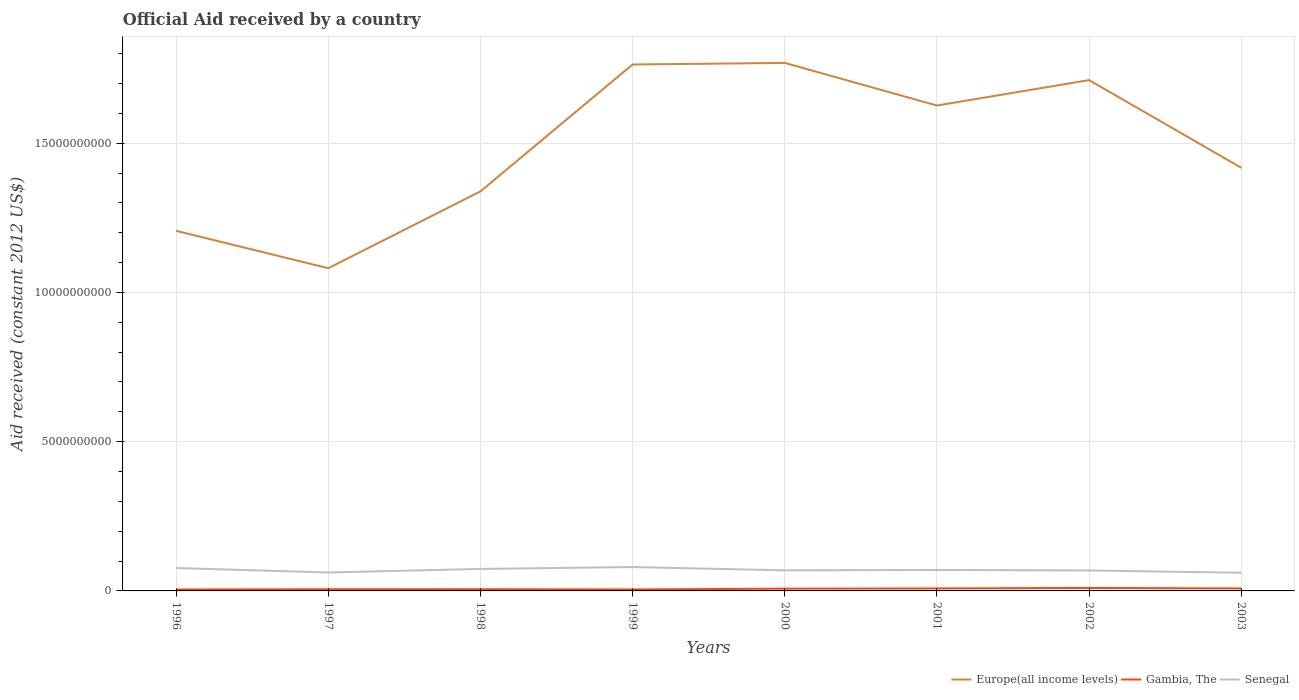Across all years, what is the maximum net official aid received in Gambia, The?
Offer a terse response. 4.86e+07. In which year was the net official aid received in Gambia, The maximum?
Offer a terse response. 1996. What is the total net official aid received in Senegal in the graph?
Keep it short and to the point. 1.58e+08. What is the difference between the highest and the second highest net official aid received in Gambia, The?
Offer a very short reply. 5.02e+07. What is the difference between the highest and the lowest net official aid received in Senegal?
Offer a terse response. 4. Does the graph contain any zero values?
Ensure brevity in your answer.  No. Where does the legend appear in the graph?
Provide a succinct answer. Bottom right. What is the title of the graph?
Your answer should be very brief. Official Aid received by a country. What is the label or title of the Y-axis?
Ensure brevity in your answer.  Aid received (constant 2012 US$). What is the Aid received (constant 2012 US$) in Europe(all income levels) in 1996?
Your answer should be very brief. 1.21e+1. What is the Aid received (constant 2012 US$) of Gambia, The in 1996?
Give a very brief answer. 4.86e+07. What is the Aid received (constant 2012 US$) in Senegal in 1996?
Keep it short and to the point. 7.67e+08. What is the Aid received (constant 2012 US$) in Europe(all income levels) in 1997?
Your answer should be compact. 1.08e+1. What is the Aid received (constant 2012 US$) of Gambia, The in 1997?
Make the answer very short. 5.61e+07. What is the Aid received (constant 2012 US$) of Senegal in 1997?
Your response must be concise. 6.17e+08. What is the Aid received (constant 2012 US$) in Europe(all income levels) in 1998?
Provide a succinct answer. 1.34e+1. What is the Aid received (constant 2012 US$) of Gambia, The in 1998?
Offer a very short reply. 5.69e+07. What is the Aid received (constant 2012 US$) in Senegal in 1998?
Your answer should be very brief. 7.37e+08. What is the Aid received (constant 2012 US$) of Europe(all income levels) in 1999?
Your answer should be very brief. 1.76e+1. What is the Aid received (constant 2012 US$) of Gambia, The in 1999?
Make the answer very short. 4.95e+07. What is the Aid received (constant 2012 US$) of Senegal in 1999?
Your response must be concise. 8.00e+08. What is the Aid received (constant 2012 US$) of Europe(all income levels) in 2000?
Offer a very short reply. 1.77e+1. What is the Aid received (constant 2012 US$) in Gambia, The in 2000?
Ensure brevity in your answer.  7.57e+07. What is the Aid received (constant 2012 US$) in Senegal in 2000?
Ensure brevity in your answer.  6.89e+08. What is the Aid received (constant 2012 US$) of Europe(all income levels) in 2001?
Provide a short and direct response. 1.63e+1. What is the Aid received (constant 2012 US$) of Gambia, The in 2001?
Offer a terse response. 8.32e+07. What is the Aid received (constant 2012 US$) of Senegal in 2001?
Ensure brevity in your answer.  7.03e+08. What is the Aid received (constant 2012 US$) in Europe(all income levels) in 2002?
Give a very brief answer. 1.71e+1. What is the Aid received (constant 2012 US$) in Gambia, The in 2002?
Ensure brevity in your answer.  9.87e+07. What is the Aid received (constant 2012 US$) in Senegal in 2002?
Your answer should be very brief. 6.85e+08. What is the Aid received (constant 2012 US$) of Europe(all income levels) in 2003?
Your answer should be very brief. 1.42e+1. What is the Aid received (constant 2012 US$) of Gambia, The in 2003?
Offer a terse response. 8.30e+07. What is the Aid received (constant 2012 US$) of Senegal in 2003?
Offer a very short reply. 6.09e+08. Across all years, what is the maximum Aid received (constant 2012 US$) of Europe(all income levels)?
Offer a terse response. 1.77e+1. Across all years, what is the maximum Aid received (constant 2012 US$) of Gambia, The?
Make the answer very short. 9.87e+07. Across all years, what is the maximum Aid received (constant 2012 US$) in Senegal?
Your answer should be very brief. 8.00e+08. Across all years, what is the minimum Aid received (constant 2012 US$) in Europe(all income levels)?
Offer a terse response. 1.08e+1. Across all years, what is the minimum Aid received (constant 2012 US$) of Gambia, The?
Keep it short and to the point. 4.86e+07. Across all years, what is the minimum Aid received (constant 2012 US$) in Senegal?
Give a very brief answer. 6.09e+08. What is the total Aid received (constant 2012 US$) in Europe(all income levels) in the graph?
Your response must be concise. 1.19e+11. What is the total Aid received (constant 2012 US$) in Gambia, The in the graph?
Offer a very short reply. 5.52e+08. What is the total Aid received (constant 2012 US$) of Senegal in the graph?
Provide a succinct answer. 5.61e+09. What is the difference between the Aid received (constant 2012 US$) in Europe(all income levels) in 1996 and that in 1997?
Give a very brief answer. 1.25e+09. What is the difference between the Aid received (constant 2012 US$) in Gambia, The in 1996 and that in 1997?
Offer a very short reply. -7.59e+06. What is the difference between the Aid received (constant 2012 US$) in Senegal in 1996 and that in 1997?
Your response must be concise. 1.49e+08. What is the difference between the Aid received (constant 2012 US$) in Europe(all income levels) in 1996 and that in 1998?
Give a very brief answer. -1.32e+09. What is the difference between the Aid received (constant 2012 US$) in Gambia, The in 1996 and that in 1998?
Offer a terse response. -8.32e+06. What is the difference between the Aid received (constant 2012 US$) of Senegal in 1996 and that in 1998?
Make the answer very short. 2.94e+07. What is the difference between the Aid received (constant 2012 US$) in Europe(all income levels) in 1996 and that in 1999?
Ensure brevity in your answer.  -5.57e+09. What is the difference between the Aid received (constant 2012 US$) in Gambia, The in 1996 and that in 1999?
Provide a short and direct response. -9.20e+05. What is the difference between the Aid received (constant 2012 US$) in Senegal in 1996 and that in 1999?
Ensure brevity in your answer.  -3.32e+07. What is the difference between the Aid received (constant 2012 US$) in Europe(all income levels) in 1996 and that in 2000?
Provide a short and direct response. -5.63e+09. What is the difference between the Aid received (constant 2012 US$) of Gambia, The in 1996 and that in 2000?
Your answer should be compact. -2.72e+07. What is the difference between the Aid received (constant 2012 US$) in Senegal in 1996 and that in 2000?
Your response must be concise. 7.72e+07. What is the difference between the Aid received (constant 2012 US$) of Europe(all income levels) in 1996 and that in 2001?
Your answer should be very brief. -4.20e+09. What is the difference between the Aid received (constant 2012 US$) of Gambia, The in 1996 and that in 2001?
Provide a short and direct response. -3.46e+07. What is the difference between the Aid received (constant 2012 US$) of Senegal in 1996 and that in 2001?
Provide a succinct answer. 6.37e+07. What is the difference between the Aid received (constant 2012 US$) in Europe(all income levels) in 1996 and that in 2002?
Provide a succinct answer. -5.05e+09. What is the difference between the Aid received (constant 2012 US$) in Gambia, The in 1996 and that in 2002?
Provide a succinct answer. -5.02e+07. What is the difference between the Aid received (constant 2012 US$) in Senegal in 1996 and that in 2002?
Keep it short and to the point. 8.17e+07. What is the difference between the Aid received (constant 2012 US$) in Europe(all income levels) in 1996 and that in 2003?
Ensure brevity in your answer.  -2.11e+09. What is the difference between the Aid received (constant 2012 US$) of Gambia, The in 1996 and that in 2003?
Your response must be concise. -3.44e+07. What is the difference between the Aid received (constant 2012 US$) in Senegal in 1996 and that in 2003?
Make the answer very short. 1.58e+08. What is the difference between the Aid received (constant 2012 US$) in Europe(all income levels) in 1997 and that in 1998?
Provide a succinct answer. -2.57e+09. What is the difference between the Aid received (constant 2012 US$) of Gambia, The in 1997 and that in 1998?
Provide a short and direct response. -7.30e+05. What is the difference between the Aid received (constant 2012 US$) in Senegal in 1997 and that in 1998?
Offer a very short reply. -1.20e+08. What is the difference between the Aid received (constant 2012 US$) of Europe(all income levels) in 1997 and that in 1999?
Provide a succinct answer. -6.82e+09. What is the difference between the Aid received (constant 2012 US$) of Gambia, The in 1997 and that in 1999?
Give a very brief answer. 6.67e+06. What is the difference between the Aid received (constant 2012 US$) of Senegal in 1997 and that in 1999?
Offer a terse response. -1.83e+08. What is the difference between the Aid received (constant 2012 US$) in Europe(all income levels) in 1997 and that in 2000?
Your answer should be compact. -6.88e+09. What is the difference between the Aid received (constant 2012 US$) of Gambia, The in 1997 and that in 2000?
Provide a short and direct response. -1.96e+07. What is the difference between the Aid received (constant 2012 US$) in Senegal in 1997 and that in 2000?
Your answer should be compact. -7.22e+07. What is the difference between the Aid received (constant 2012 US$) of Europe(all income levels) in 1997 and that in 2001?
Your answer should be compact. -5.45e+09. What is the difference between the Aid received (constant 2012 US$) of Gambia, The in 1997 and that in 2001?
Offer a terse response. -2.71e+07. What is the difference between the Aid received (constant 2012 US$) in Senegal in 1997 and that in 2001?
Offer a terse response. -8.58e+07. What is the difference between the Aid received (constant 2012 US$) of Europe(all income levels) in 1997 and that in 2002?
Offer a terse response. -6.30e+09. What is the difference between the Aid received (constant 2012 US$) in Gambia, The in 1997 and that in 2002?
Your response must be concise. -4.26e+07. What is the difference between the Aid received (constant 2012 US$) of Senegal in 1997 and that in 2002?
Your answer should be very brief. -6.78e+07. What is the difference between the Aid received (constant 2012 US$) in Europe(all income levels) in 1997 and that in 2003?
Provide a succinct answer. -3.37e+09. What is the difference between the Aid received (constant 2012 US$) in Gambia, The in 1997 and that in 2003?
Ensure brevity in your answer.  -2.69e+07. What is the difference between the Aid received (constant 2012 US$) of Senegal in 1997 and that in 2003?
Provide a short and direct response. 8.65e+06. What is the difference between the Aid received (constant 2012 US$) of Europe(all income levels) in 1998 and that in 1999?
Offer a terse response. -4.25e+09. What is the difference between the Aid received (constant 2012 US$) of Gambia, The in 1998 and that in 1999?
Provide a succinct answer. 7.40e+06. What is the difference between the Aid received (constant 2012 US$) of Senegal in 1998 and that in 1999?
Offer a very short reply. -6.26e+07. What is the difference between the Aid received (constant 2012 US$) in Europe(all income levels) in 1998 and that in 2000?
Offer a very short reply. -4.30e+09. What is the difference between the Aid received (constant 2012 US$) in Gambia, The in 1998 and that in 2000?
Your answer should be very brief. -1.88e+07. What is the difference between the Aid received (constant 2012 US$) of Senegal in 1998 and that in 2000?
Your answer should be compact. 4.78e+07. What is the difference between the Aid received (constant 2012 US$) in Europe(all income levels) in 1998 and that in 2001?
Keep it short and to the point. -2.88e+09. What is the difference between the Aid received (constant 2012 US$) in Gambia, The in 1998 and that in 2001?
Provide a succinct answer. -2.63e+07. What is the difference between the Aid received (constant 2012 US$) of Senegal in 1998 and that in 2001?
Your answer should be compact. 3.43e+07. What is the difference between the Aid received (constant 2012 US$) in Europe(all income levels) in 1998 and that in 2002?
Provide a short and direct response. -3.73e+09. What is the difference between the Aid received (constant 2012 US$) of Gambia, The in 1998 and that in 2002?
Keep it short and to the point. -4.19e+07. What is the difference between the Aid received (constant 2012 US$) in Senegal in 1998 and that in 2002?
Your answer should be compact. 5.23e+07. What is the difference between the Aid received (constant 2012 US$) of Europe(all income levels) in 1998 and that in 2003?
Your response must be concise. -7.91e+08. What is the difference between the Aid received (constant 2012 US$) of Gambia, The in 1998 and that in 2003?
Provide a short and direct response. -2.61e+07. What is the difference between the Aid received (constant 2012 US$) in Senegal in 1998 and that in 2003?
Provide a short and direct response. 1.29e+08. What is the difference between the Aid received (constant 2012 US$) of Europe(all income levels) in 1999 and that in 2000?
Your answer should be compact. -5.37e+07. What is the difference between the Aid received (constant 2012 US$) in Gambia, The in 1999 and that in 2000?
Ensure brevity in your answer.  -2.62e+07. What is the difference between the Aid received (constant 2012 US$) of Senegal in 1999 and that in 2000?
Ensure brevity in your answer.  1.10e+08. What is the difference between the Aid received (constant 2012 US$) of Europe(all income levels) in 1999 and that in 2001?
Make the answer very short. 1.37e+09. What is the difference between the Aid received (constant 2012 US$) of Gambia, The in 1999 and that in 2001?
Offer a very short reply. -3.37e+07. What is the difference between the Aid received (constant 2012 US$) of Senegal in 1999 and that in 2001?
Your response must be concise. 9.70e+07. What is the difference between the Aid received (constant 2012 US$) of Europe(all income levels) in 1999 and that in 2002?
Give a very brief answer. 5.22e+08. What is the difference between the Aid received (constant 2012 US$) in Gambia, The in 1999 and that in 2002?
Your answer should be compact. -4.93e+07. What is the difference between the Aid received (constant 2012 US$) in Senegal in 1999 and that in 2002?
Make the answer very short. 1.15e+08. What is the difference between the Aid received (constant 2012 US$) of Europe(all income levels) in 1999 and that in 2003?
Keep it short and to the point. 3.46e+09. What is the difference between the Aid received (constant 2012 US$) of Gambia, The in 1999 and that in 2003?
Provide a succinct answer. -3.35e+07. What is the difference between the Aid received (constant 2012 US$) in Senegal in 1999 and that in 2003?
Ensure brevity in your answer.  1.91e+08. What is the difference between the Aid received (constant 2012 US$) of Europe(all income levels) in 2000 and that in 2001?
Offer a very short reply. 1.43e+09. What is the difference between the Aid received (constant 2012 US$) of Gambia, The in 2000 and that in 2001?
Your answer should be compact. -7.49e+06. What is the difference between the Aid received (constant 2012 US$) of Senegal in 2000 and that in 2001?
Provide a succinct answer. -1.35e+07. What is the difference between the Aid received (constant 2012 US$) in Europe(all income levels) in 2000 and that in 2002?
Provide a short and direct response. 5.76e+08. What is the difference between the Aid received (constant 2012 US$) in Gambia, The in 2000 and that in 2002?
Offer a terse response. -2.30e+07. What is the difference between the Aid received (constant 2012 US$) in Senegal in 2000 and that in 2002?
Make the answer very short. 4.49e+06. What is the difference between the Aid received (constant 2012 US$) in Europe(all income levels) in 2000 and that in 2003?
Give a very brief answer. 3.51e+09. What is the difference between the Aid received (constant 2012 US$) in Gambia, The in 2000 and that in 2003?
Offer a very short reply. -7.29e+06. What is the difference between the Aid received (constant 2012 US$) in Senegal in 2000 and that in 2003?
Provide a succinct answer. 8.09e+07. What is the difference between the Aid received (constant 2012 US$) of Europe(all income levels) in 2001 and that in 2002?
Your response must be concise. -8.52e+08. What is the difference between the Aid received (constant 2012 US$) of Gambia, The in 2001 and that in 2002?
Your response must be concise. -1.55e+07. What is the difference between the Aid received (constant 2012 US$) in Senegal in 2001 and that in 2002?
Your answer should be compact. 1.80e+07. What is the difference between the Aid received (constant 2012 US$) in Europe(all income levels) in 2001 and that in 2003?
Ensure brevity in your answer.  2.08e+09. What is the difference between the Aid received (constant 2012 US$) of Senegal in 2001 and that in 2003?
Offer a terse response. 9.44e+07. What is the difference between the Aid received (constant 2012 US$) of Europe(all income levels) in 2002 and that in 2003?
Provide a succinct answer. 2.94e+09. What is the difference between the Aid received (constant 2012 US$) in Gambia, The in 2002 and that in 2003?
Your response must be concise. 1.57e+07. What is the difference between the Aid received (constant 2012 US$) in Senegal in 2002 and that in 2003?
Offer a very short reply. 7.64e+07. What is the difference between the Aid received (constant 2012 US$) in Europe(all income levels) in 1996 and the Aid received (constant 2012 US$) in Gambia, The in 1997?
Ensure brevity in your answer.  1.20e+1. What is the difference between the Aid received (constant 2012 US$) of Europe(all income levels) in 1996 and the Aid received (constant 2012 US$) of Senegal in 1997?
Offer a terse response. 1.14e+1. What is the difference between the Aid received (constant 2012 US$) of Gambia, The in 1996 and the Aid received (constant 2012 US$) of Senegal in 1997?
Make the answer very short. -5.69e+08. What is the difference between the Aid received (constant 2012 US$) of Europe(all income levels) in 1996 and the Aid received (constant 2012 US$) of Gambia, The in 1998?
Make the answer very short. 1.20e+1. What is the difference between the Aid received (constant 2012 US$) in Europe(all income levels) in 1996 and the Aid received (constant 2012 US$) in Senegal in 1998?
Give a very brief answer. 1.13e+1. What is the difference between the Aid received (constant 2012 US$) of Gambia, The in 1996 and the Aid received (constant 2012 US$) of Senegal in 1998?
Your answer should be very brief. -6.89e+08. What is the difference between the Aid received (constant 2012 US$) of Europe(all income levels) in 1996 and the Aid received (constant 2012 US$) of Gambia, The in 1999?
Offer a very short reply. 1.20e+1. What is the difference between the Aid received (constant 2012 US$) in Europe(all income levels) in 1996 and the Aid received (constant 2012 US$) in Senegal in 1999?
Make the answer very short. 1.13e+1. What is the difference between the Aid received (constant 2012 US$) of Gambia, The in 1996 and the Aid received (constant 2012 US$) of Senegal in 1999?
Provide a short and direct response. -7.51e+08. What is the difference between the Aid received (constant 2012 US$) in Europe(all income levels) in 1996 and the Aid received (constant 2012 US$) in Gambia, The in 2000?
Make the answer very short. 1.20e+1. What is the difference between the Aid received (constant 2012 US$) of Europe(all income levels) in 1996 and the Aid received (constant 2012 US$) of Senegal in 2000?
Give a very brief answer. 1.14e+1. What is the difference between the Aid received (constant 2012 US$) of Gambia, The in 1996 and the Aid received (constant 2012 US$) of Senegal in 2000?
Your response must be concise. -6.41e+08. What is the difference between the Aid received (constant 2012 US$) in Europe(all income levels) in 1996 and the Aid received (constant 2012 US$) in Gambia, The in 2001?
Give a very brief answer. 1.20e+1. What is the difference between the Aid received (constant 2012 US$) in Europe(all income levels) in 1996 and the Aid received (constant 2012 US$) in Senegal in 2001?
Make the answer very short. 1.14e+1. What is the difference between the Aid received (constant 2012 US$) in Gambia, The in 1996 and the Aid received (constant 2012 US$) in Senegal in 2001?
Your answer should be compact. -6.54e+08. What is the difference between the Aid received (constant 2012 US$) in Europe(all income levels) in 1996 and the Aid received (constant 2012 US$) in Gambia, The in 2002?
Keep it short and to the point. 1.20e+1. What is the difference between the Aid received (constant 2012 US$) in Europe(all income levels) in 1996 and the Aid received (constant 2012 US$) in Senegal in 2002?
Offer a very short reply. 1.14e+1. What is the difference between the Aid received (constant 2012 US$) of Gambia, The in 1996 and the Aid received (constant 2012 US$) of Senegal in 2002?
Your answer should be compact. -6.36e+08. What is the difference between the Aid received (constant 2012 US$) in Europe(all income levels) in 1996 and the Aid received (constant 2012 US$) in Gambia, The in 2003?
Ensure brevity in your answer.  1.20e+1. What is the difference between the Aid received (constant 2012 US$) in Europe(all income levels) in 1996 and the Aid received (constant 2012 US$) in Senegal in 2003?
Provide a short and direct response. 1.15e+1. What is the difference between the Aid received (constant 2012 US$) of Gambia, The in 1996 and the Aid received (constant 2012 US$) of Senegal in 2003?
Make the answer very short. -5.60e+08. What is the difference between the Aid received (constant 2012 US$) of Europe(all income levels) in 1997 and the Aid received (constant 2012 US$) of Gambia, The in 1998?
Provide a succinct answer. 1.08e+1. What is the difference between the Aid received (constant 2012 US$) in Europe(all income levels) in 1997 and the Aid received (constant 2012 US$) in Senegal in 1998?
Your answer should be compact. 1.01e+1. What is the difference between the Aid received (constant 2012 US$) in Gambia, The in 1997 and the Aid received (constant 2012 US$) in Senegal in 1998?
Give a very brief answer. -6.81e+08. What is the difference between the Aid received (constant 2012 US$) of Europe(all income levels) in 1997 and the Aid received (constant 2012 US$) of Gambia, The in 1999?
Provide a succinct answer. 1.08e+1. What is the difference between the Aid received (constant 2012 US$) of Europe(all income levels) in 1997 and the Aid received (constant 2012 US$) of Senegal in 1999?
Give a very brief answer. 1.00e+1. What is the difference between the Aid received (constant 2012 US$) of Gambia, The in 1997 and the Aid received (constant 2012 US$) of Senegal in 1999?
Offer a terse response. -7.44e+08. What is the difference between the Aid received (constant 2012 US$) in Europe(all income levels) in 1997 and the Aid received (constant 2012 US$) in Gambia, The in 2000?
Keep it short and to the point. 1.07e+1. What is the difference between the Aid received (constant 2012 US$) in Europe(all income levels) in 1997 and the Aid received (constant 2012 US$) in Senegal in 2000?
Your answer should be very brief. 1.01e+1. What is the difference between the Aid received (constant 2012 US$) in Gambia, The in 1997 and the Aid received (constant 2012 US$) in Senegal in 2000?
Provide a short and direct response. -6.33e+08. What is the difference between the Aid received (constant 2012 US$) of Europe(all income levels) in 1997 and the Aid received (constant 2012 US$) of Gambia, The in 2001?
Ensure brevity in your answer.  1.07e+1. What is the difference between the Aid received (constant 2012 US$) in Europe(all income levels) in 1997 and the Aid received (constant 2012 US$) in Senegal in 2001?
Keep it short and to the point. 1.01e+1. What is the difference between the Aid received (constant 2012 US$) of Gambia, The in 1997 and the Aid received (constant 2012 US$) of Senegal in 2001?
Offer a terse response. -6.47e+08. What is the difference between the Aid received (constant 2012 US$) in Europe(all income levels) in 1997 and the Aid received (constant 2012 US$) in Gambia, The in 2002?
Offer a very short reply. 1.07e+1. What is the difference between the Aid received (constant 2012 US$) in Europe(all income levels) in 1997 and the Aid received (constant 2012 US$) in Senegal in 2002?
Provide a short and direct response. 1.01e+1. What is the difference between the Aid received (constant 2012 US$) of Gambia, The in 1997 and the Aid received (constant 2012 US$) of Senegal in 2002?
Provide a short and direct response. -6.29e+08. What is the difference between the Aid received (constant 2012 US$) of Europe(all income levels) in 1997 and the Aid received (constant 2012 US$) of Gambia, The in 2003?
Your answer should be compact. 1.07e+1. What is the difference between the Aid received (constant 2012 US$) of Europe(all income levels) in 1997 and the Aid received (constant 2012 US$) of Senegal in 2003?
Make the answer very short. 1.02e+1. What is the difference between the Aid received (constant 2012 US$) of Gambia, The in 1997 and the Aid received (constant 2012 US$) of Senegal in 2003?
Make the answer very short. -5.52e+08. What is the difference between the Aid received (constant 2012 US$) of Europe(all income levels) in 1998 and the Aid received (constant 2012 US$) of Gambia, The in 1999?
Your answer should be very brief. 1.33e+1. What is the difference between the Aid received (constant 2012 US$) in Europe(all income levels) in 1998 and the Aid received (constant 2012 US$) in Senegal in 1999?
Give a very brief answer. 1.26e+1. What is the difference between the Aid received (constant 2012 US$) of Gambia, The in 1998 and the Aid received (constant 2012 US$) of Senegal in 1999?
Ensure brevity in your answer.  -7.43e+08. What is the difference between the Aid received (constant 2012 US$) in Europe(all income levels) in 1998 and the Aid received (constant 2012 US$) in Gambia, The in 2000?
Your answer should be compact. 1.33e+1. What is the difference between the Aid received (constant 2012 US$) in Europe(all income levels) in 1998 and the Aid received (constant 2012 US$) in Senegal in 2000?
Provide a succinct answer. 1.27e+1. What is the difference between the Aid received (constant 2012 US$) in Gambia, The in 1998 and the Aid received (constant 2012 US$) in Senegal in 2000?
Keep it short and to the point. -6.33e+08. What is the difference between the Aid received (constant 2012 US$) in Europe(all income levels) in 1998 and the Aid received (constant 2012 US$) in Gambia, The in 2001?
Your answer should be compact. 1.33e+1. What is the difference between the Aid received (constant 2012 US$) in Europe(all income levels) in 1998 and the Aid received (constant 2012 US$) in Senegal in 2001?
Your answer should be compact. 1.27e+1. What is the difference between the Aid received (constant 2012 US$) in Gambia, The in 1998 and the Aid received (constant 2012 US$) in Senegal in 2001?
Make the answer very short. -6.46e+08. What is the difference between the Aid received (constant 2012 US$) of Europe(all income levels) in 1998 and the Aid received (constant 2012 US$) of Gambia, The in 2002?
Keep it short and to the point. 1.33e+1. What is the difference between the Aid received (constant 2012 US$) in Europe(all income levels) in 1998 and the Aid received (constant 2012 US$) in Senegal in 2002?
Provide a succinct answer. 1.27e+1. What is the difference between the Aid received (constant 2012 US$) in Gambia, The in 1998 and the Aid received (constant 2012 US$) in Senegal in 2002?
Give a very brief answer. -6.28e+08. What is the difference between the Aid received (constant 2012 US$) of Europe(all income levels) in 1998 and the Aid received (constant 2012 US$) of Gambia, The in 2003?
Your answer should be compact. 1.33e+1. What is the difference between the Aid received (constant 2012 US$) in Europe(all income levels) in 1998 and the Aid received (constant 2012 US$) in Senegal in 2003?
Your answer should be very brief. 1.28e+1. What is the difference between the Aid received (constant 2012 US$) in Gambia, The in 1998 and the Aid received (constant 2012 US$) in Senegal in 2003?
Offer a very short reply. -5.52e+08. What is the difference between the Aid received (constant 2012 US$) in Europe(all income levels) in 1999 and the Aid received (constant 2012 US$) in Gambia, The in 2000?
Make the answer very short. 1.76e+1. What is the difference between the Aid received (constant 2012 US$) in Europe(all income levels) in 1999 and the Aid received (constant 2012 US$) in Senegal in 2000?
Ensure brevity in your answer.  1.69e+1. What is the difference between the Aid received (constant 2012 US$) of Gambia, The in 1999 and the Aid received (constant 2012 US$) of Senegal in 2000?
Offer a very short reply. -6.40e+08. What is the difference between the Aid received (constant 2012 US$) of Europe(all income levels) in 1999 and the Aid received (constant 2012 US$) of Gambia, The in 2001?
Your answer should be very brief. 1.76e+1. What is the difference between the Aid received (constant 2012 US$) in Europe(all income levels) in 1999 and the Aid received (constant 2012 US$) in Senegal in 2001?
Keep it short and to the point. 1.69e+1. What is the difference between the Aid received (constant 2012 US$) of Gambia, The in 1999 and the Aid received (constant 2012 US$) of Senegal in 2001?
Offer a terse response. -6.54e+08. What is the difference between the Aid received (constant 2012 US$) in Europe(all income levels) in 1999 and the Aid received (constant 2012 US$) in Gambia, The in 2002?
Give a very brief answer. 1.75e+1. What is the difference between the Aid received (constant 2012 US$) in Europe(all income levels) in 1999 and the Aid received (constant 2012 US$) in Senegal in 2002?
Your answer should be very brief. 1.70e+1. What is the difference between the Aid received (constant 2012 US$) of Gambia, The in 1999 and the Aid received (constant 2012 US$) of Senegal in 2002?
Your response must be concise. -6.36e+08. What is the difference between the Aid received (constant 2012 US$) in Europe(all income levels) in 1999 and the Aid received (constant 2012 US$) in Gambia, The in 2003?
Ensure brevity in your answer.  1.76e+1. What is the difference between the Aid received (constant 2012 US$) in Europe(all income levels) in 1999 and the Aid received (constant 2012 US$) in Senegal in 2003?
Provide a short and direct response. 1.70e+1. What is the difference between the Aid received (constant 2012 US$) in Gambia, The in 1999 and the Aid received (constant 2012 US$) in Senegal in 2003?
Your answer should be compact. -5.59e+08. What is the difference between the Aid received (constant 2012 US$) of Europe(all income levels) in 2000 and the Aid received (constant 2012 US$) of Gambia, The in 2001?
Keep it short and to the point. 1.76e+1. What is the difference between the Aid received (constant 2012 US$) in Europe(all income levels) in 2000 and the Aid received (constant 2012 US$) in Senegal in 2001?
Your answer should be compact. 1.70e+1. What is the difference between the Aid received (constant 2012 US$) in Gambia, The in 2000 and the Aid received (constant 2012 US$) in Senegal in 2001?
Offer a very short reply. -6.27e+08. What is the difference between the Aid received (constant 2012 US$) of Europe(all income levels) in 2000 and the Aid received (constant 2012 US$) of Gambia, The in 2002?
Provide a succinct answer. 1.76e+1. What is the difference between the Aid received (constant 2012 US$) in Europe(all income levels) in 2000 and the Aid received (constant 2012 US$) in Senegal in 2002?
Offer a terse response. 1.70e+1. What is the difference between the Aid received (constant 2012 US$) in Gambia, The in 2000 and the Aid received (constant 2012 US$) in Senegal in 2002?
Provide a succinct answer. -6.09e+08. What is the difference between the Aid received (constant 2012 US$) in Europe(all income levels) in 2000 and the Aid received (constant 2012 US$) in Gambia, The in 2003?
Offer a very short reply. 1.76e+1. What is the difference between the Aid received (constant 2012 US$) of Europe(all income levels) in 2000 and the Aid received (constant 2012 US$) of Senegal in 2003?
Provide a succinct answer. 1.71e+1. What is the difference between the Aid received (constant 2012 US$) in Gambia, The in 2000 and the Aid received (constant 2012 US$) in Senegal in 2003?
Ensure brevity in your answer.  -5.33e+08. What is the difference between the Aid received (constant 2012 US$) of Europe(all income levels) in 2001 and the Aid received (constant 2012 US$) of Gambia, The in 2002?
Provide a short and direct response. 1.62e+1. What is the difference between the Aid received (constant 2012 US$) of Europe(all income levels) in 2001 and the Aid received (constant 2012 US$) of Senegal in 2002?
Provide a short and direct response. 1.56e+1. What is the difference between the Aid received (constant 2012 US$) in Gambia, The in 2001 and the Aid received (constant 2012 US$) in Senegal in 2002?
Provide a short and direct response. -6.02e+08. What is the difference between the Aid received (constant 2012 US$) of Europe(all income levels) in 2001 and the Aid received (constant 2012 US$) of Gambia, The in 2003?
Offer a terse response. 1.62e+1. What is the difference between the Aid received (constant 2012 US$) in Europe(all income levels) in 2001 and the Aid received (constant 2012 US$) in Senegal in 2003?
Your response must be concise. 1.57e+1. What is the difference between the Aid received (constant 2012 US$) in Gambia, The in 2001 and the Aid received (constant 2012 US$) in Senegal in 2003?
Ensure brevity in your answer.  -5.25e+08. What is the difference between the Aid received (constant 2012 US$) of Europe(all income levels) in 2002 and the Aid received (constant 2012 US$) of Gambia, The in 2003?
Give a very brief answer. 1.70e+1. What is the difference between the Aid received (constant 2012 US$) of Europe(all income levels) in 2002 and the Aid received (constant 2012 US$) of Senegal in 2003?
Offer a very short reply. 1.65e+1. What is the difference between the Aid received (constant 2012 US$) of Gambia, The in 2002 and the Aid received (constant 2012 US$) of Senegal in 2003?
Your answer should be compact. -5.10e+08. What is the average Aid received (constant 2012 US$) in Europe(all income levels) per year?
Offer a terse response. 1.49e+1. What is the average Aid received (constant 2012 US$) in Gambia, The per year?
Ensure brevity in your answer.  6.90e+07. What is the average Aid received (constant 2012 US$) in Senegal per year?
Provide a short and direct response. 7.01e+08. In the year 1996, what is the difference between the Aid received (constant 2012 US$) in Europe(all income levels) and Aid received (constant 2012 US$) in Gambia, The?
Provide a succinct answer. 1.20e+1. In the year 1996, what is the difference between the Aid received (constant 2012 US$) in Europe(all income levels) and Aid received (constant 2012 US$) in Senegal?
Provide a short and direct response. 1.13e+1. In the year 1996, what is the difference between the Aid received (constant 2012 US$) in Gambia, The and Aid received (constant 2012 US$) in Senegal?
Your answer should be very brief. -7.18e+08. In the year 1997, what is the difference between the Aid received (constant 2012 US$) in Europe(all income levels) and Aid received (constant 2012 US$) in Gambia, The?
Your response must be concise. 1.08e+1. In the year 1997, what is the difference between the Aid received (constant 2012 US$) in Europe(all income levels) and Aid received (constant 2012 US$) in Senegal?
Provide a succinct answer. 1.02e+1. In the year 1997, what is the difference between the Aid received (constant 2012 US$) of Gambia, The and Aid received (constant 2012 US$) of Senegal?
Your answer should be compact. -5.61e+08. In the year 1998, what is the difference between the Aid received (constant 2012 US$) in Europe(all income levels) and Aid received (constant 2012 US$) in Gambia, The?
Offer a terse response. 1.33e+1. In the year 1998, what is the difference between the Aid received (constant 2012 US$) of Europe(all income levels) and Aid received (constant 2012 US$) of Senegal?
Ensure brevity in your answer.  1.26e+1. In the year 1998, what is the difference between the Aid received (constant 2012 US$) of Gambia, The and Aid received (constant 2012 US$) of Senegal?
Ensure brevity in your answer.  -6.80e+08. In the year 1999, what is the difference between the Aid received (constant 2012 US$) of Europe(all income levels) and Aid received (constant 2012 US$) of Gambia, The?
Provide a succinct answer. 1.76e+1. In the year 1999, what is the difference between the Aid received (constant 2012 US$) in Europe(all income levels) and Aid received (constant 2012 US$) in Senegal?
Give a very brief answer. 1.68e+1. In the year 1999, what is the difference between the Aid received (constant 2012 US$) in Gambia, The and Aid received (constant 2012 US$) in Senegal?
Ensure brevity in your answer.  -7.50e+08. In the year 2000, what is the difference between the Aid received (constant 2012 US$) of Europe(all income levels) and Aid received (constant 2012 US$) of Gambia, The?
Offer a very short reply. 1.76e+1. In the year 2000, what is the difference between the Aid received (constant 2012 US$) in Europe(all income levels) and Aid received (constant 2012 US$) in Senegal?
Provide a succinct answer. 1.70e+1. In the year 2000, what is the difference between the Aid received (constant 2012 US$) in Gambia, The and Aid received (constant 2012 US$) in Senegal?
Make the answer very short. -6.14e+08. In the year 2001, what is the difference between the Aid received (constant 2012 US$) in Europe(all income levels) and Aid received (constant 2012 US$) in Gambia, The?
Offer a very short reply. 1.62e+1. In the year 2001, what is the difference between the Aid received (constant 2012 US$) in Europe(all income levels) and Aid received (constant 2012 US$) in Senegal?
Provide a short and direct response. 1.56e+1. In the year 2001, what is the difference between the Aid received (constant 2012 US$) in Gambia, The and Aid received (constant 2012 US$) in Senegal?
Offer a very short reply. -6.20e+08. In the year 2002, what is the difference between the Aid received (constant 2012 US$) in Europe(all income levels) and Aid received (constant 2012 US$) in Gambia, The?
Your answer should be very brief. 1.70e+1. In the year 2002, what is the difference between the Aid received (constant 2012 US$) in Europe(all income levels) and Aid received (constant 2012 US$) in Senegal?
Provide a short and direct response. 1.64e+1. In the year 2002, what is the difference between the Aid received (constant 2012 US$) in Gambia, The and Aid received (constant 2012 US$) in Senegal?
Your answer should be compact. -5.86e+08. In the year 2003, what is the difference between the Aid received (constant 2012 US$) of Europe(all income levels) and Aid received (constant 2012 US$) of Gambia, The?
Keep it short and to the point. 1.41e+1. In the year 2003, what is the difference between the Aid received (constant 2012 US$) in Europe(all income levels) and Aid received (constant 2012 US$) in Senegal?
Give a very brief answer. 1.36e+1. In the year 2003, what is the difference between the Aid received (constant 2012 US$) in Gambia, The and Aid received (constant 2012 US$) in Senegal?
Keep it short and to the point. -5.26e+08. What is the ratio of the Aid received (constant 2012 US$) of Europe(all income levels) in 1996 to that in 1997?
Offer a very short reply. 1.12. What is the ratio of the Aid received (constant 2012 US$) in Gambia, The in 1996 to that in 1997?
Provide a succinct answer. 0.86. What is the ratio of the Aid received (constant 2012 US$) in Senegal in 1996 to that in 1997?
Your response must be concise. 1.24. What is the ratio of the Aid received (constant 2012 US$) in Europe(all income levels) in 1996 to that in 1998?
Keep it short and to the point. 0.9. What is the ratio of the Aid received (constant 2012 US$) in Gambia, The in 1996 to that in 1998?
Provide a short and direct response. 0.85. What is the ratio of the Aid received (constant 2012 US$) in Senegal in 1996 to that in 1998?
Give a very brief answer. 1.04. What is the ratio of the Aid received (constant 2012 US$) in Europe(all income levels) in 1996 to that in 1999?
Your answer should be very brief. 0.68. What is the ratio of the Aid received (constant 2012 US$) in Gambia, The in 1996 to that in 1999?
Provide a short and direct response. 0.98. What is the ratio of the Aid received (constant 2012 US$) in Senegal in 1996 to that in 1999?
Provide a succinct answer. 0.96. What is the ratio of the Aid received (constant 2012 US$) in Europe(all income levels) in 1996 to that in 2000?
Your response must be concise. 0.68. What is the ratio of the Aid received (constant 2012 US$) of Gambia, The in 1996 to that in 2000?
Provide a short and direct response. 0.64. What is the ratio of the Aid received (constant 2012 US$) in Senegal in 1996 to that in 2000?
Your response must be concise. 1.11. What is the ratio of the Aid received (constant 2012 US$) of Europe(all income levels) in 1996 to that in 2001?
Ensure brevity in your answer.  0.74. What is the ratio of the Aid received (constant 2012 US$) of Gambia, The in 1996 to that in 2001?
Keep it short and to the point. 0.58. What is the ratio of the Aid received (constant 2012 US$) in Senegal in 1996 to that in 2001?
Keep it short and to the point. 1.09. What is the ratio of the Aid received (constant 2012 US$) of Europe(all income levels) in 1996 to that in 2002?
Provide a short and direct response. 0.7. What is the ratio of the Aid received (constant 2012 US$) of Gambia, The in 1996 to that in 2002?
Offer a terse response. 0.49. What is the ratio of the Aid received (constant 2012 US$) in Senegal in 1996 to that in 2002?
Provide a succinct answer. 1.12. What is the ratio of the Aid received (constant 2012 US$) in Europe(all income levels) in 1996 to that in 2003?
Ensure brevity in your answer.  0.85. What is the ratio of the Aid received (constant 2012 US$) of Gambia, The in 1996 to that in 2003?
Your response must be concise. 0.58. What is the ratio of the Aid received (constant 2012 US$) in Senegal in 1996 to that in 2003?
Your answer should be compact. 1.26. What is the ratio of the Aid received (constant 2012 US$) in Europe(all income levels) in 1997 to that in 1998?
Give a very brief answer. 0.81. What is the ratio of the Aid received (constant 2012 US$) in Gambia, The in 1997 to that in 1998?
Make the answer very short. 0.99. What is the ratio of the Aid received (constant 2012 US$) in Senegal in 1997 to that in 1998?
Provide a succinct answer. 0.84. What is the ratio of the Aid received (constant 2012 US$) of Europe(all income levels) in 1997 to that in 1999?
Ensure brevity in your answer.  0.61. What is the ratio of the Aid received (constant 2012 US$) in Gambia, The in 1997 to that in 1999?
Ensure brevity in your answer.  1.13. What is the ratio of the Aid received (constant 2012 US$) in Senegal in 1997 to that in 1999?
Offer a very short reply. 0.77. What is the ratio of the Aid received (constant 2012 US$) of Europe(all income levels) in 1997 to that in 2000?
Provide a succinct answer. 0.61. What is the ratio of the Aid received (constant 2012 US$) of Gambia, The in 1997 to that in 2000?
Make the answer very short. 0.74. What is the ratio of the Aid received (constant 2012 US$) of Senegal in 1997 to that in 2000?
Make the answer very short. 0.9. What is the ratio of the Aid received (constant 2012 US$) of Europe(all income levels) in 1997 to that in 2001?
Ensure brevity in your answer.  0.66. What is the ratio of the Aid received (constant 2012 US$) in Gambia, The in 1997 to that in 2001?
Give a very brief answer. 0.67. What is the ratio of the Aid received (constant 2012 US$) in Senegal in 1997 to that in 2001?
Ensure brevity in your answer.  0.88. What is the ratio of the Aid received (constant 2012 US$) of Europe(all income levels) in 1997 to that in 2002?
Keep it short and to the point. 0.63. What is the ratio of the Aid received (constant 2012 US$) in Gambia, The in 1997 to that in 2002?
Offer a terse response. 0.57. What is the ratio of the Aid received (constant 2012 US$) in Senegal in 1997 to that in 2002?
Ensure brevity in your answer.  0.9. What is the ratio of the Aid received (constant 2012 US$) in Europe(all income levels) in 1997 to that in 2003?
Offer a very short reply. 0.76. What is the ratio of the Aid received (constant 2012 US$) of Gambia, The in 1997 to that in 2003?
Your answer should be compact. 0.68. What is the ratio of the Aid received (constant 2012 US$) of Senegal in 1997 to that in 2003?
Provide a short and direct response. 1.01. What is the ratio of the Aid received (constant 2012 US$) in Europe(all income levels) in 1998 to that in 1999?
Ensure brevity in your answer.  0.76. What is the ratio of the Aid received (constant 2012 US$) of Gambia, The in 1998 to that in 1999?
Your response must be concise. 1.15. What is the ratio of the Aid received (constant 2012 US$) of Senegal in 1998 to that in 1999?
Give a very brief answer. 0.92. What is the ratio of the Aid received (constant 2012 US$) in Europe(all income levels) in 1998 to that in 2000?
Ensure brevity in your answer.  0.76. What is the ratio of the Aid received (constant 2012 US$) in Gambia, The in 1998 to that in 2000?
Your response must be concise. 0.75. What is the ratio of the Aid received (constant 2012 US$) of Senegal in 1998 to that in 2000?
Your answer should be very brief. 1.07. What is the ratio of the Aid received (constant 2012 US$) of Europe(all income levels) in 1998 to that in 2001?
Give a very brief answer. 0.82. What is the ratio of the Aid received (constant 2012 US$) of Gambia, The in 1998 to that in 2001?
Offer a terse response. 0.68. What is the ratio of the Aid received (constant 2012 US$) of Senegal in 1998 to that in 2001?
Provide a short and direct response. 1.05. What is the ratio of the Aid received (constant 2012 US$) in Europe(all income levels) in 1998 to that in 2002?
Ensure brevity in your answer.  0.78. What is the ratio of the Aid received (constant 2012 US$) in Gambia, The in 1998 to that in 2002?
Your answer should be compact. 0.58. What is the ratio of the Aid received (constant 2012 US$) in Senegal in 1998 to that in 2002?
Your answer should be very brief. 1.08. What is the ratio of the Aid received (constant 2012 US$) of Europe(all income levels) in 1998 to that in 2003?
Offer a very short reply. 0.94. What is the ratio of the Aid received (constant 2012 US$) of Gambia, The in 1998 to that in 2003?
Provide a succinct answer. 0.69. What is the ratio of the Aid received (constant 2012 US$) in Senegal in 1998 to that in 2003?
Make the answer very short. 1.21. What is the ratio of the Aid received (constant 2012 US$) in Europe(all income levels) in 1999 to that in 2000?
Your response must be concise. 1. What is the ratio of the Aid received (constant 2012 US$) of Gambia, The in 1999 to that in 2000?
Your answer should be very brief. 0.65. What is the ratio of the Aid received (constant 2012 US$) in Senegal in 1999 to that in 2000?
Offer a very short reply. 1.16. What is the ratio of the Aid received (constant 2012 US$) in Europe(all income levels) in 1999 to that in 2001?
Your response must be concise. 1.08. What is the ratio of the Aid received (constant 2012 US$) of Gambia, The in 1999 to that in 2001?
Your answer should be compact. 0.59. What is the ratio of the Aid received (constant 2012 US$) in Senegal in 1999 to that in 2001?
Your response must be concise. 1.14. What is the ratio of the Aid received (constant 2012 US$) in Europe(all income levels) in 1999 to that in 2002?
Make the answer very short. 1.03. What is the ratio of the Aid received (constant 2012 US$) of Gambia, The in 1999 to that in 2002?
Ensure brevity in your answer.  0.5. What is the ratio of the Aid received (constant 2012 US$) of Senegal in 1999 to that in 2002?
Offer a very short reply. 1.17. What is the ratio of the Aid received (constant 2012 US$) in Europe(all income levels) in 1999 to that in 2003?
Provide a short and direct response. 1.24. What is the ratio of the Aid received (constant 2012 US$) in Gambia, The in 1999 to that in 2003?
Your answer should be very brief. 0.6. What is the ratio of the Aid received (constant 2012 US$) of Senegal in 1999 to that in 2003?
Ensure brevity in your answer.  1.31. What is the ratio of the Aid received (constant 2012 US$) of Europe(all income levels) in 2000 to that in 2001?
Provide a short and direct response. 1.09. What is the ratio of the Aid received (constant 2012 US$) in Gambia, The in 2000 to that in 2001?
Your answer should be compact. 0.91. What is the ratio of the Aid received (constant 2012 US$) of Senegal in 2000 to that in 2001?
Your answer should be compact. 0.98. What is the ratio of the Aid received (constant 2012 US$) of Europe(all income levels) in 2000 to that in 2002?
Provide a short and direct response. 1.03. What is the ratio of the Aid received (constant 2012 US$) in Gambia, The in 2000 to that in 2002?
Ensure brevity in your answer.  0.77. What is the ratio of the Aid received (constant 2012 US$) in Senegal in 2000 to that in 2002?
Make the answer very short. 1.01. What is the ratio of the Aid received (constant 2012 US$) in Europe(all income levels) in 2000 to that in 2003?
Provide a short and direct response. 1.25. What is the ratio of the Aid received (constant 2012 US$) in Gambia, The in 2000 to that in 2003?
Keep it short and to the point. 0.91. What is the ratio of the Aid received (constant 2012 US$) in Senegal in 2000 to that in 2003?
Make the answer very short. 1.13. What is the ratio of the Aid received (constant 2012 US$) in Europe(all income levels) in 2001 to that in 2002?
Provide a succinct answer. 0.95. What is the ratio of the Aid received (constant 2012 US$) in Gambia, The in 2001 to that in 2002?
Provide a succinct answer. 0.84. What is the ratio of the Aid received (constant 2012 US$) in Senegal in 2001 to that in 2002?
Offer a terse response. 1.03. What is the ratio of the Aid received (constant 2012 US$) of Europe(all income levels) in 2001 to that in 2003?
Ensure brevity in your answer.  1.15. What is the ratio of the Aid received (constant 2012 US$) in Senegal in 2001 to that in 2003?
Your answer should be compact. 1.16. What is the ratio of the Aid received (constant 2012 US$) in Europe(all income levels) in 2002 to that in 2003?
Keep it short and to the point. 1.21. What is the ratio of the Aid received (constant 2012 US$) of Gambia, The in 2002 to that in 2003?
Your answer should be very brief. 1.19. What is the ratio of the Aid received (constant 2012 US$) of Senegal in 2002 to that in 2003?
Your answer should be very brief. 1.13. What is the difference between the highest and the second highest Aid received (constant 2012 US$) in Europe(all income levels)?
Make the answer very short. 5.37e+07. What is the difference between the highest and the second highest Aid received (constant 2012 US$) of Gambia, The?
Give a very brief answer. 1.55e+07. What is the difference between the highest and the second highest Aid received (constant 2012 US$) in Senegal?
Your response must be concise. 3.32e+07. What is the difference between the highest and the lowest Aid received (constant 2012 US$) in Europe(all income levels)?
Provide a succinct answer. 6.88e+09. What is the difference between the highest and the lowest Aid received (constant 2012 US$) of Gambia, The?
Keep it short and to the point. 5.02e+07. What is the difference between the highest and the lowest Aid received (constant 2012 US$) of Senegal?
Your answer should be compact. 1.91e+08. 